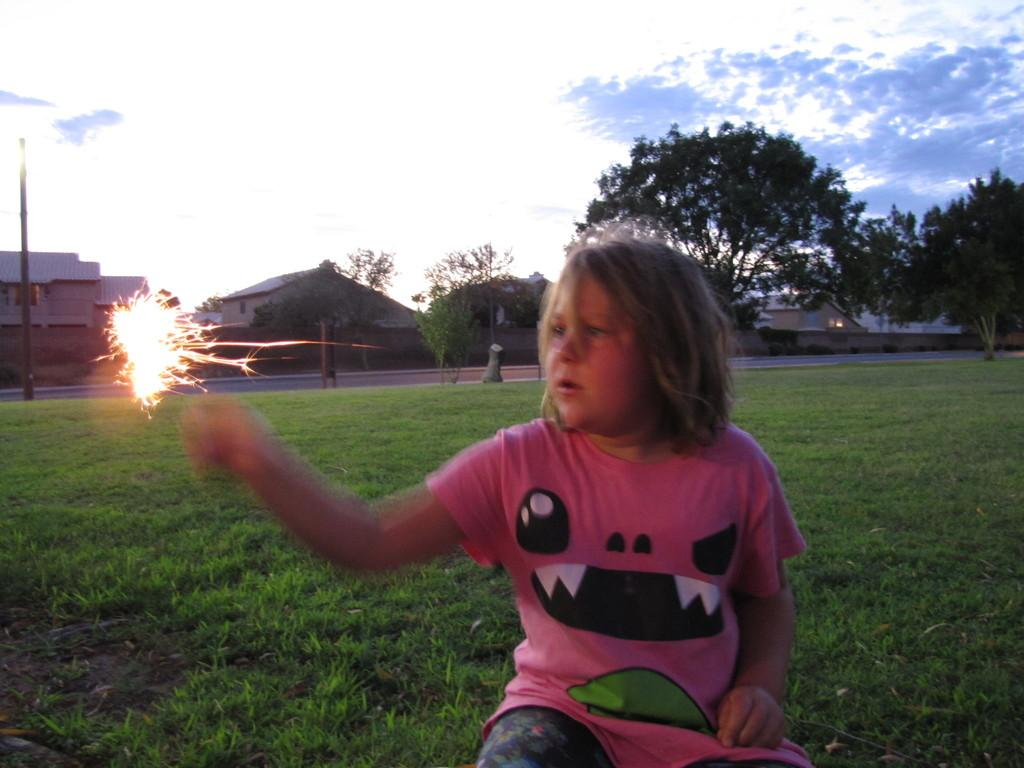Who is the main subject in the image? There is a girl in the image. What is the girl doing in the image? The girl is sitting on the grassy land. What is the girl wearing in the image? The girl is wearing a pink t-shirt. What can be seen in the background of the image? There are trees and houses in the background of the image. What is the condition of the sky in the image? The sky is full of clouds. What type of leather material can be seen on the girl's shoes in the image? There is no mention of shoes or leather material in the image; the girl is only described as wearing a pink t-shirt. 